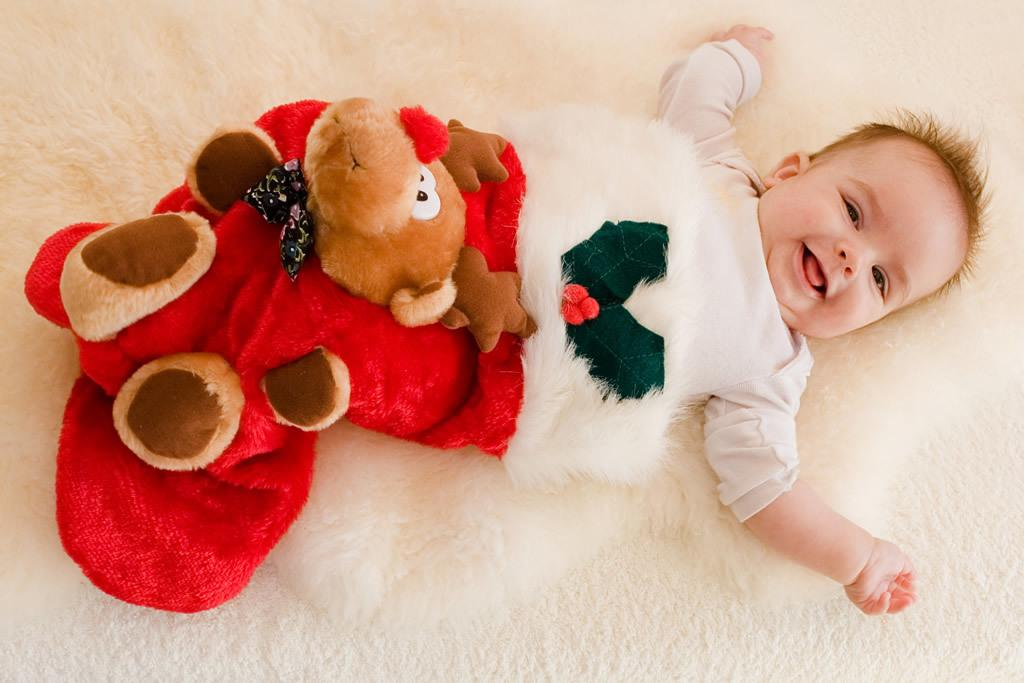What is the main subject of the image? The main subject of the image is a baby. What is the baby wearing? The baby is wearing clothes. What is the baby's facial expression? The baby is smiling. Where is the baby located in the image? The baby is lying on a bed. What type of sticks can be seen in the baby's hand in the image? There are no sticks present in the image; the baby is not holding anything. 